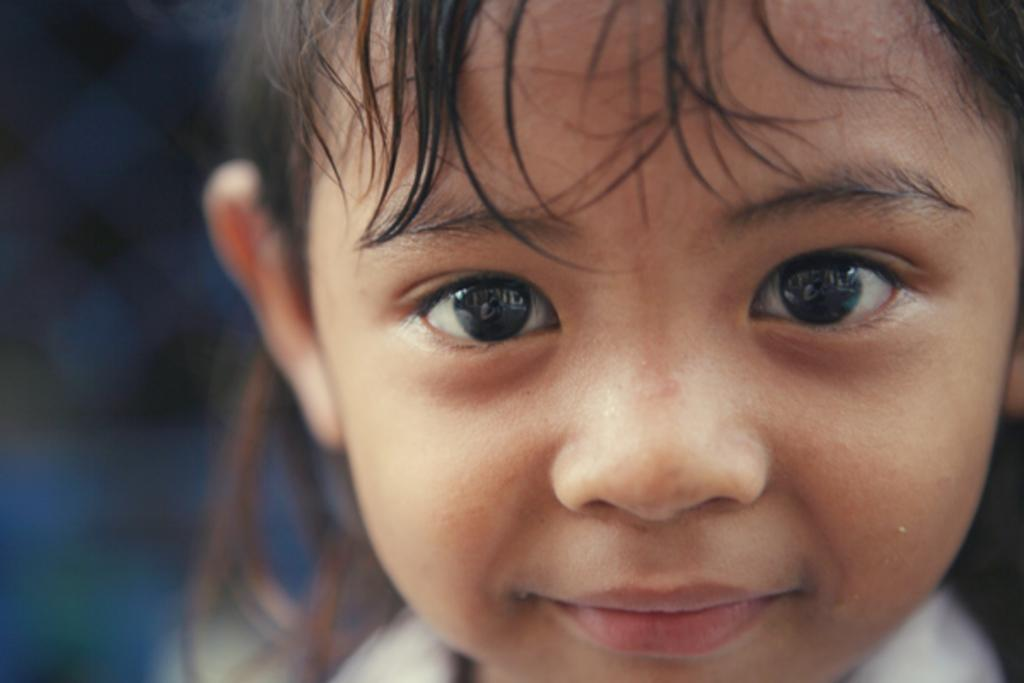Who is the main subject in the image? There is a girl in the image. What is the girl wearing? The girl is wearing a white dress. What expression does the girl have? The girl is smiling. What detail can be observed about the girl's eyes? The girl's eyes appear to show a woman. What is the condition of the left side of the image? There is a blurred area on the left side of the image. What type of beef is being cooked in the image? There is no beef present in the image; it features a girl with a specific expression and detail about her eyes. What force is being applied to the coal in the image? There is no coal or force present in the image; it focuses on a girl and her appearance. 